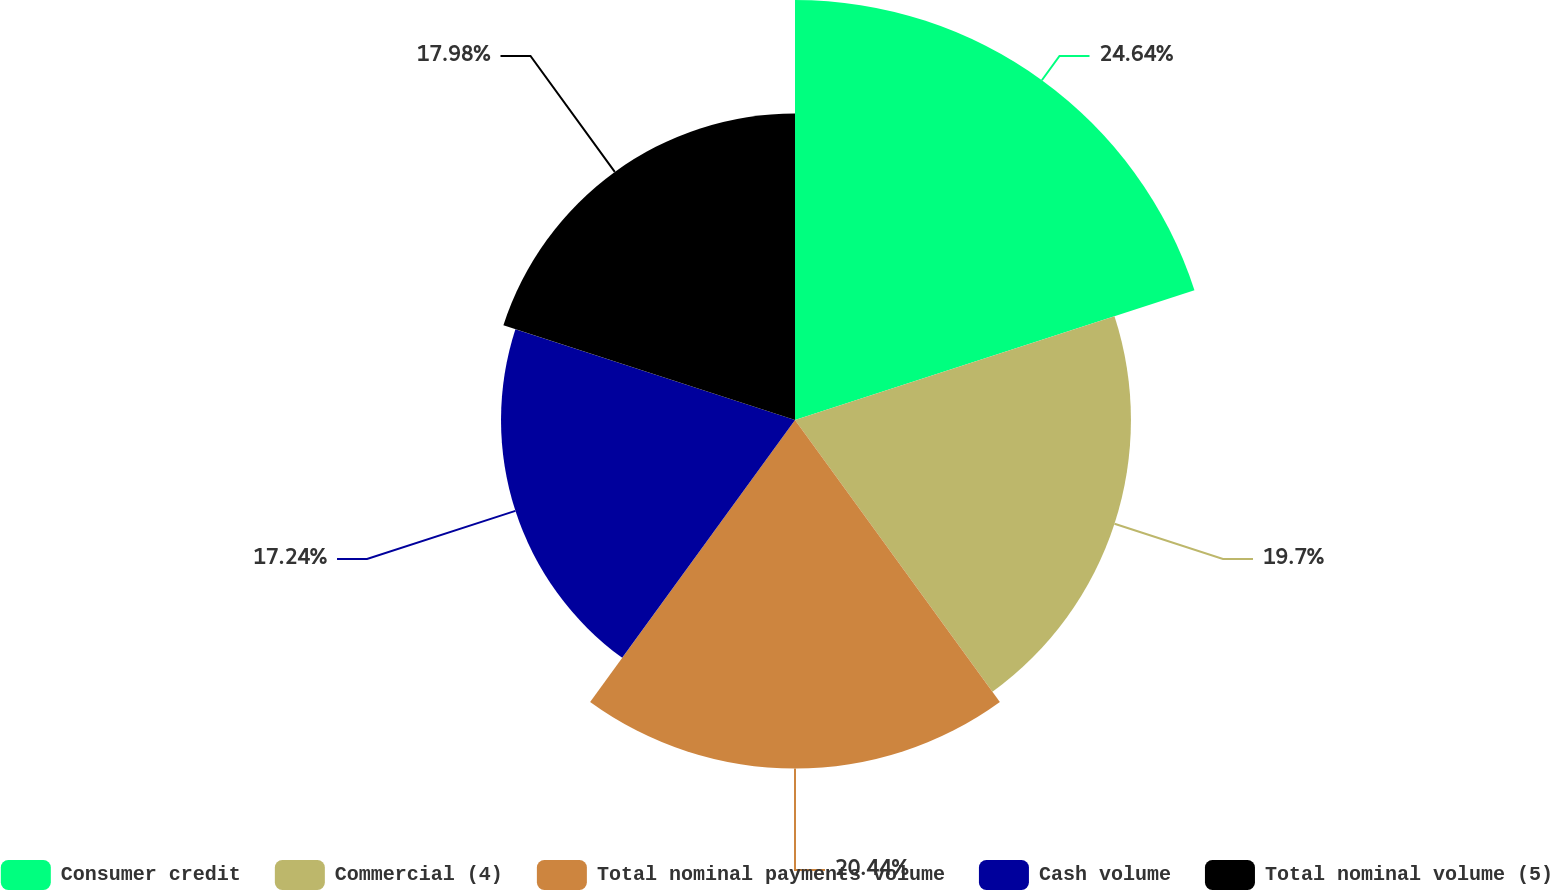<chart> <loc_0><loc_0><loc_500><loc_500><pie_chart><fcel>Consumer credit<fcel>Commercial (4)<fcel>Total nominal payments volume<fcel>Cash volume<fcel>Total nominal volume (5)<nl><fcel>24.63%<fcel>19.7%<fcel>20.44%<fcel>17.24%<fcel>17.98%<nl></chart> 